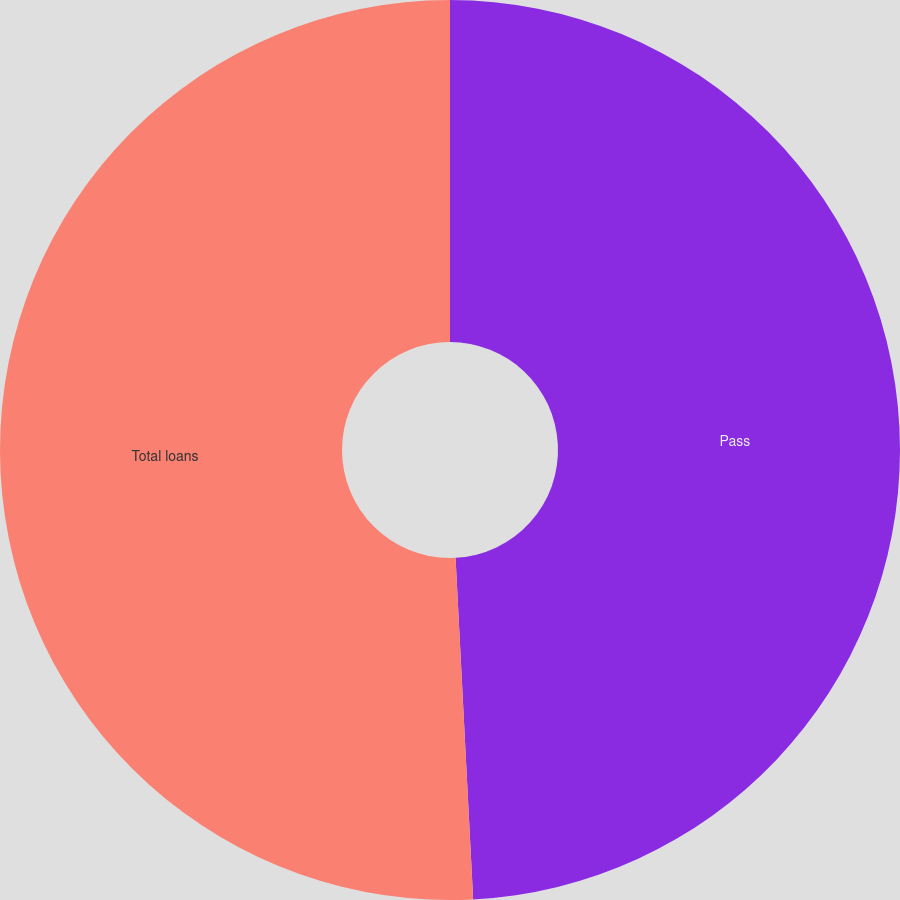<chart> <loc_0><loc_0><loc_500><loc_500><pie_chart><fcel>Pass<fcel>Total loans<nl><fcel>49.18%<fcel>50.82%<nl></chart> 